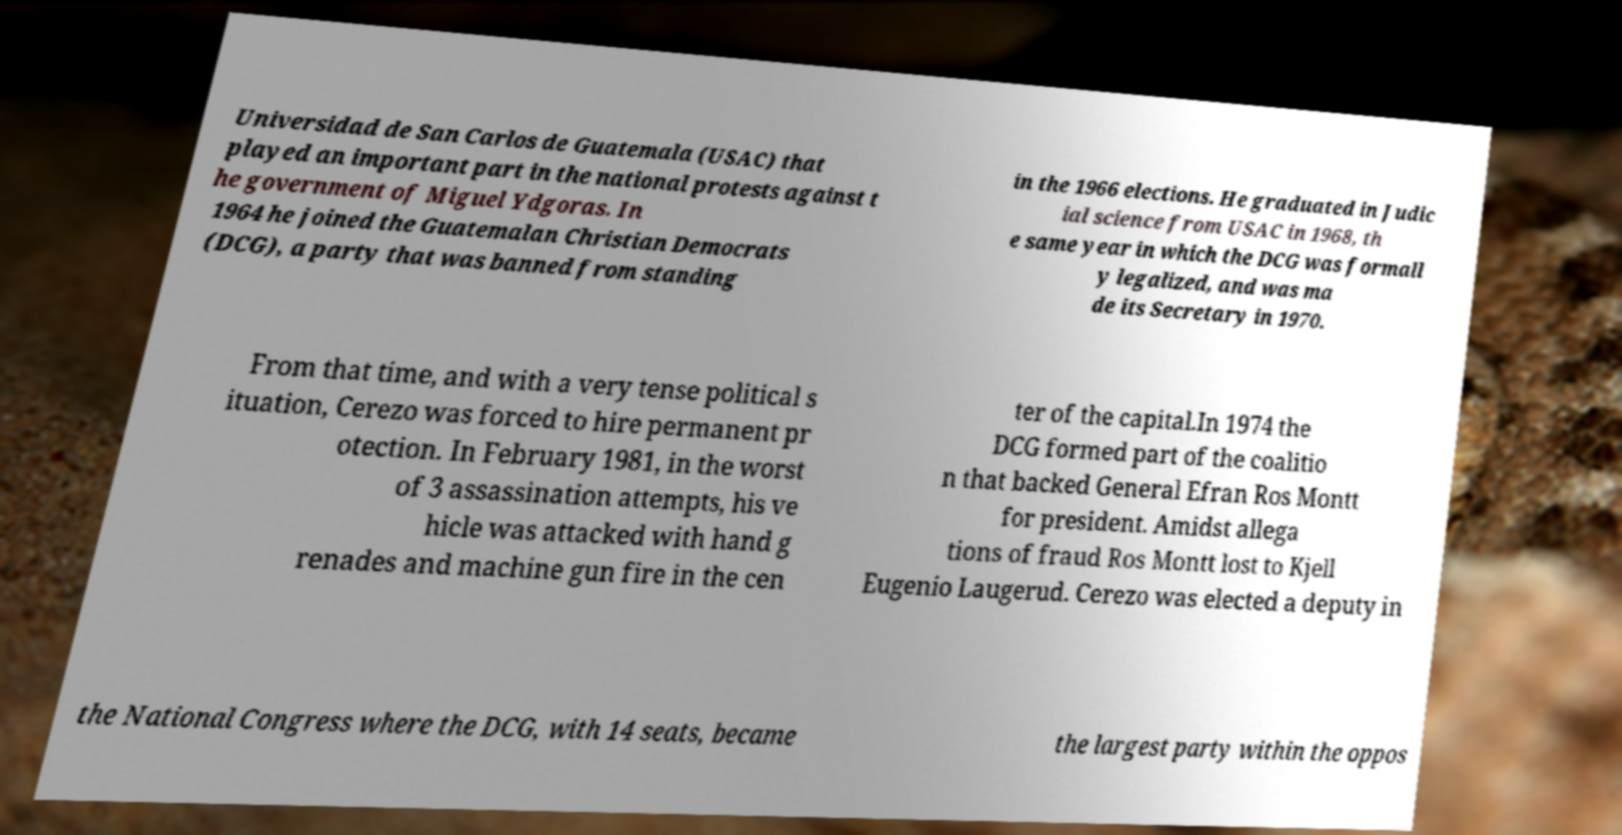Can you accurately transcribe the text from the provided image for me? Universidad de San Carlos de Guatemala (USAC) that played an important part in the national protests against t he government of Miguel Ydgoras. In 1964 he joined the Guatemalan Christian Democrats (DCG), a party that was banned from standing in the 1966 elections. He graduated in Judic ial science from USAC in 1968, th e same year in which the DCG was formall y legalized, and was ma de its Secretary in 1970. From that time, and with a very tense political s ituation, Cerezo was forced to hire permanent pr otection. In February 1981, in the worst of 3 assassination attempts, his ve hicle was attacked with hand g renades and machine gun fire in the cen ter of the capital.In 1974 the DCG formed part of the coalitio n that backed General Efran Ros Montt for president. Amidst allega tions of fraud Ros Montt lost to Kjell Eugenio Laugerud. Cerezo was elected a deputy in the National Congress where the DCG, with 14 seats, became the largest party within the oppos 